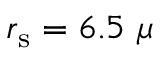Convert formula to latex. <formula><loc_0><loc_0><loc_500><loc_500>r _ { s } = 6 . 5 \mu</formula> 